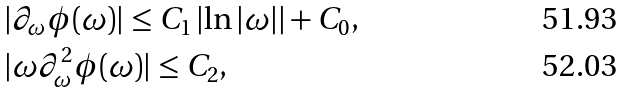<formula> <loc_0><loc_0><loc_500><loc_500>& | \partial _ { \omega } \phi ( \omega ) | \leq C _ { 1 } \left | \ln | \omega | \right | + C _ { 0 } , \\ & | \omega \partial _ { \omega } ^ { 2 } \phi ( \omega ) | \leq C _ { 2 } ,</formula> 